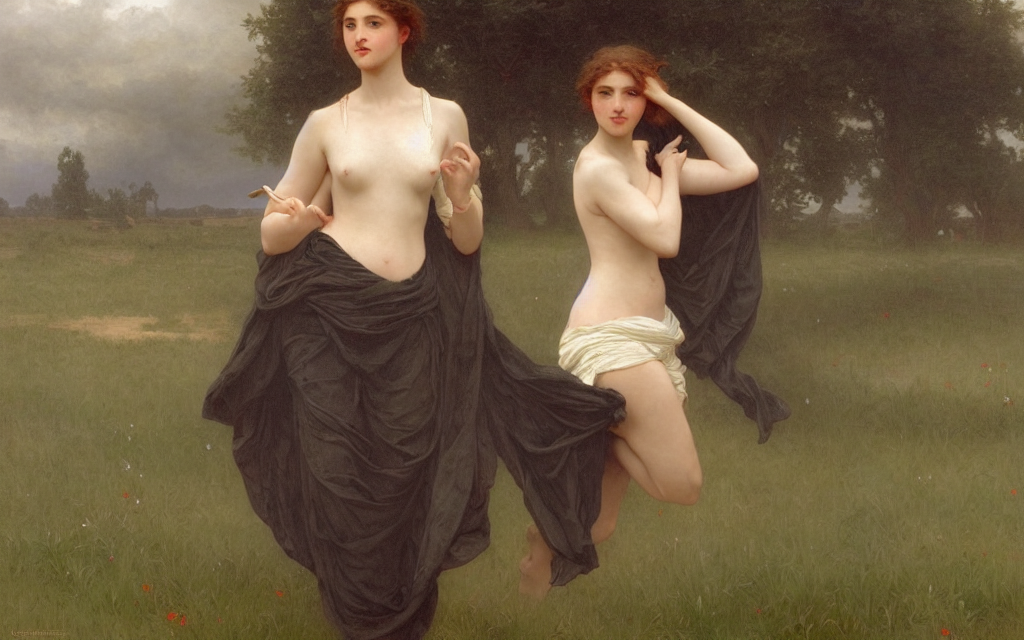What painting style is reflected in this artwork? This artwork is painted in a Neoclassical style, characterized by its clarity, harmony, and emphasis on idealized figures drawn from classical antiquity. 